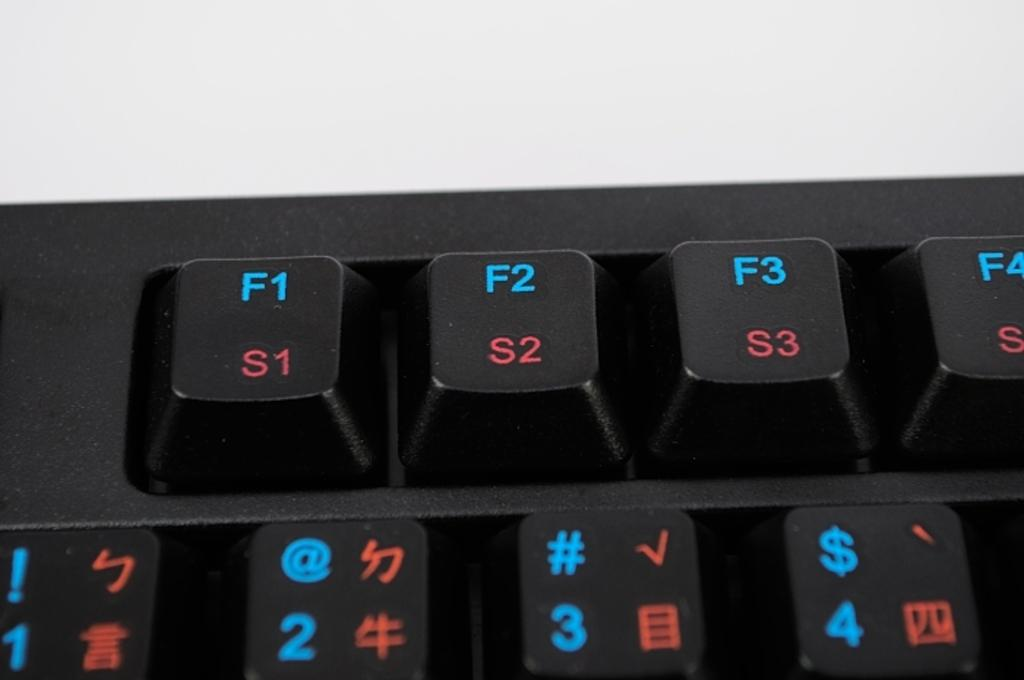What color are the keyboard keys in the image? The keyboard keys in the image are black. What types of characters can be found on the keyboard keys? There are letters, numbers, and symbols on the keyboard keys. Where is the goose sitting on the keyboard in the image? There is no goose present in the image; it only features a keyboard with black keys and various characters. 